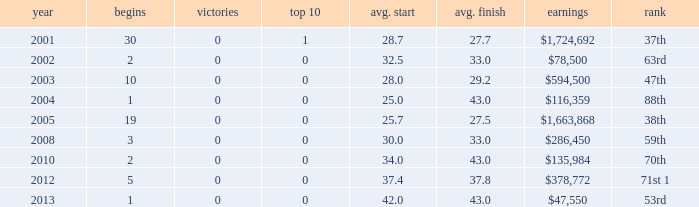How many wins for average start less than 25? 0.0. 